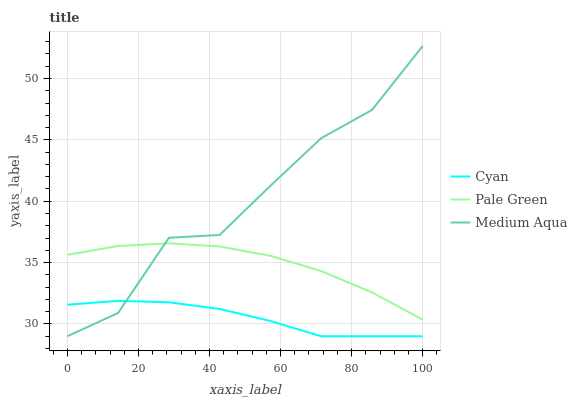Does Cyan have the minimum area under the curve?
Answer yes or no. Yes. Does Medium Aqua have the maximum area under the curve?
Answer yes or no. Yes. Does Pale Green have the minimum area under the curve?
Answer yes or no. No. Does Pale Green have the maximum area under the curve?
Answer yes or no. No. Is Cyan the smoothest?
Answer yes or no. Yes. Is Medium Aqua the roughest?
Answer yes or no. Yes. Is Pale Green the smoothest?
Answer yes or no. No. Is Pale Green the roughest?
Answer yes or no. No. Does Pale Green have the lowest value?
Answer yes or no. No. Does Pale Green have the highest value?
Answer yes or no. No. Is Cyan less than Pale Green?
Answer yes or no. Yes. Is Pale Green greater than Cyan?
Answer yes or no. Yes. Does Cyan intersect Pale Green?
Answer yes or no. No. 